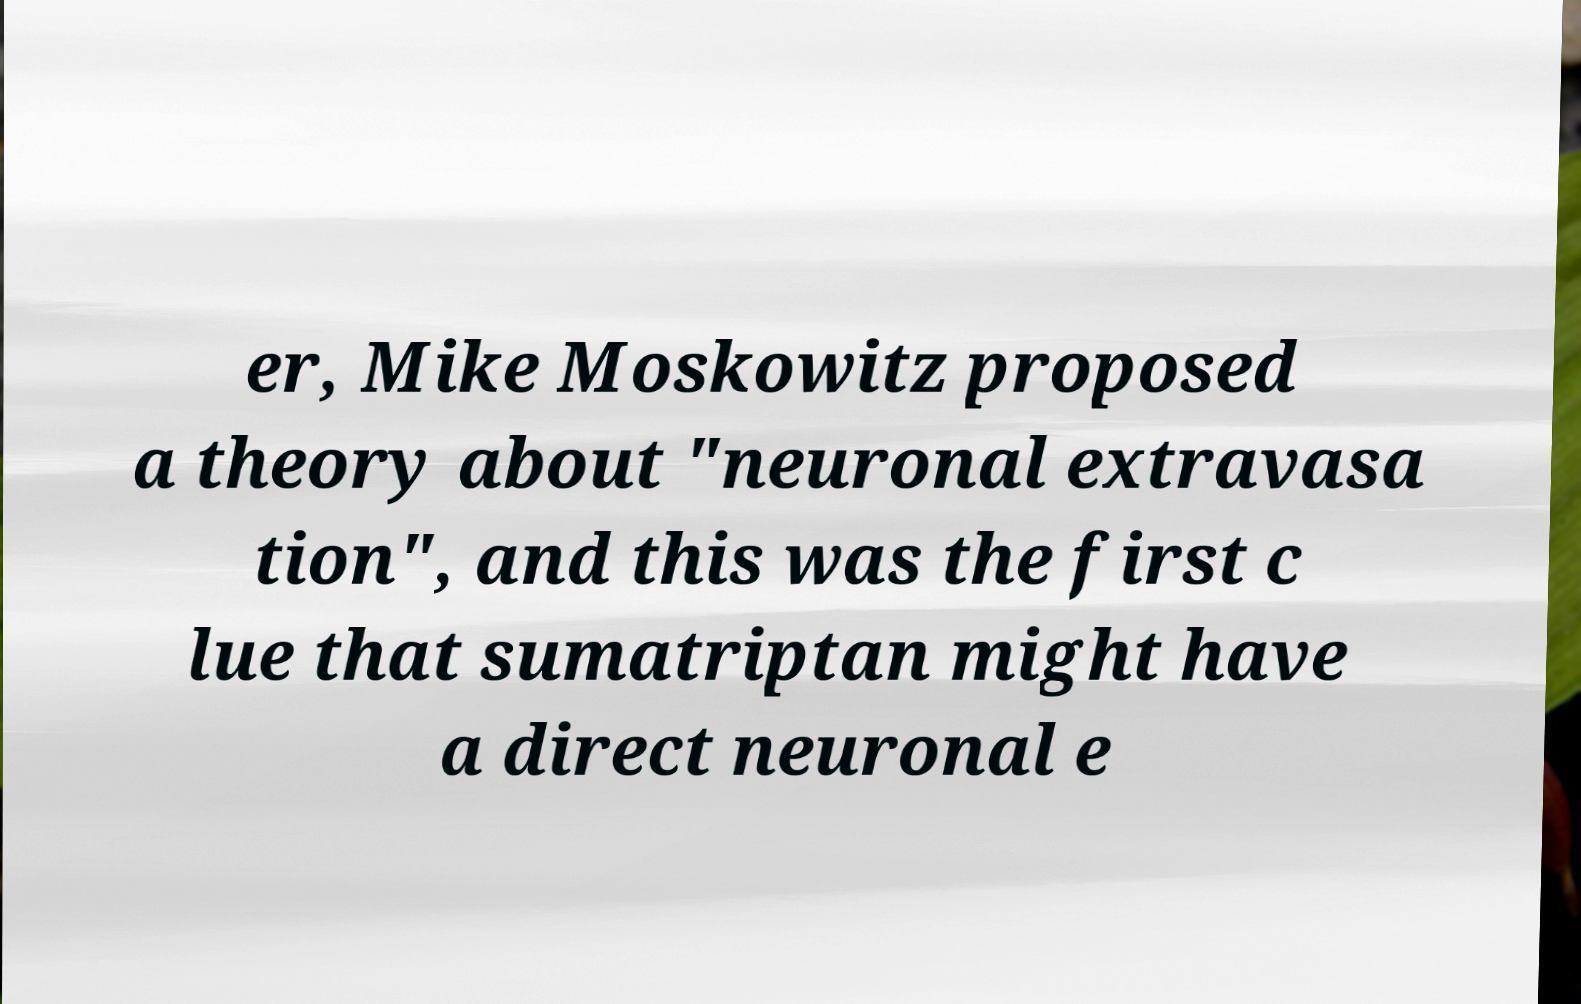For documentation purposes, I need the text within this image transcribed. Could you provide that? er, Mike Moskowitz proposed a theory about "neuronal extravasa tion", and this was the first c lue that sumatriptan might have a direct neuronal e 